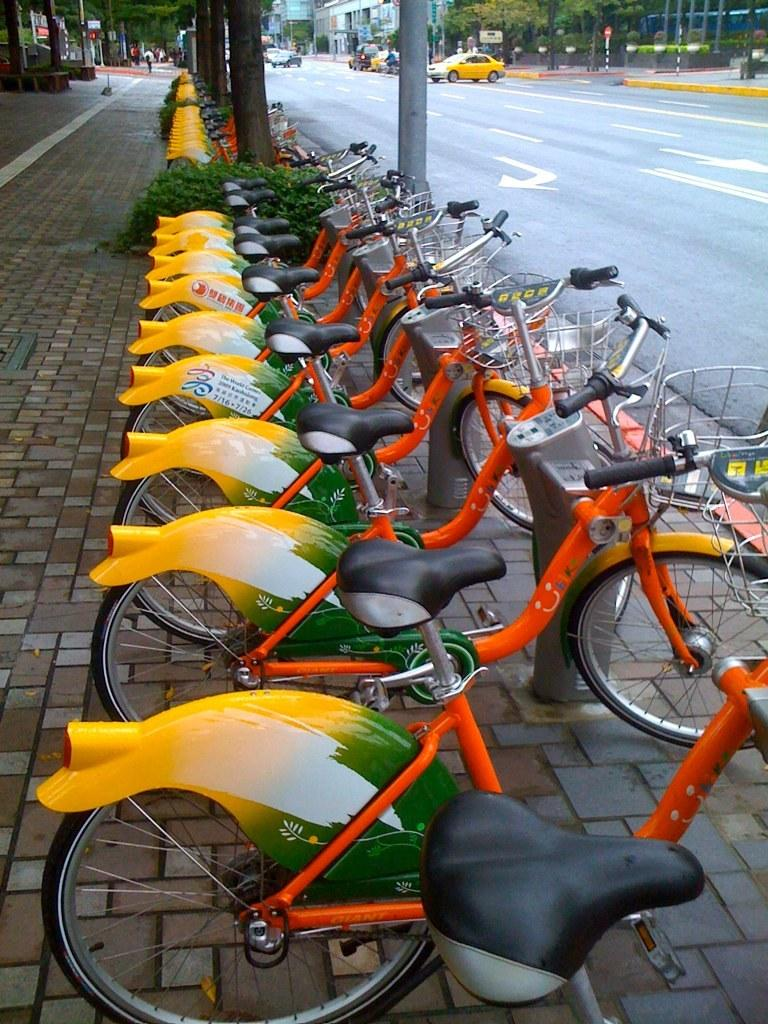What type of vehicles can be seen on the road in the image? There are vehicles on the road in the image. What is the structure where the cycles are parked? The cycles are parked at a cycle stand in the image. What is the surface that people might walk on in the image? There is a pavement at the bottom of the image. What type of natural elements can be seen in the image? There are trees in the image. What is the tall, vertical object in the image? There is a pole in the image. Can you see the ocean in the image? No, the ocean is not present in the image. What type of flesh can be seen on the vehicles in the image? There is no flesh visible on the vehicles in the image. 